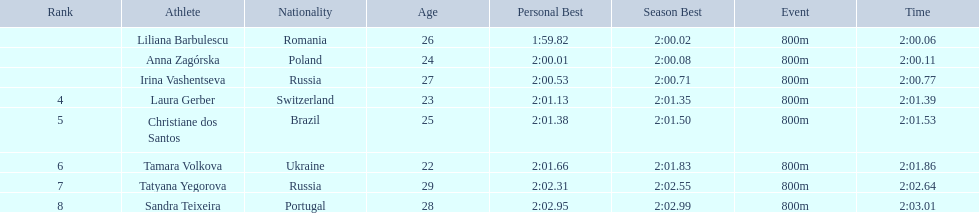Who are all of the athletes? Liliana Barbulescu, Anna Zagórska, Irina Vashentseva, Laura Gerber, Christiane dos Santos, Tamara Volkova, Tatyana Yegorova, Sandra Teixeira. What were their times in the heat? 2:00.06, 2:00.11, 2:00.77, 2:01.39, 2:01.53, 2:01.86, 2:02.64, 2:03.01. Of these, which is the top time? 2:00.06. Which athlete had this time? Liliana Barbulescu. 